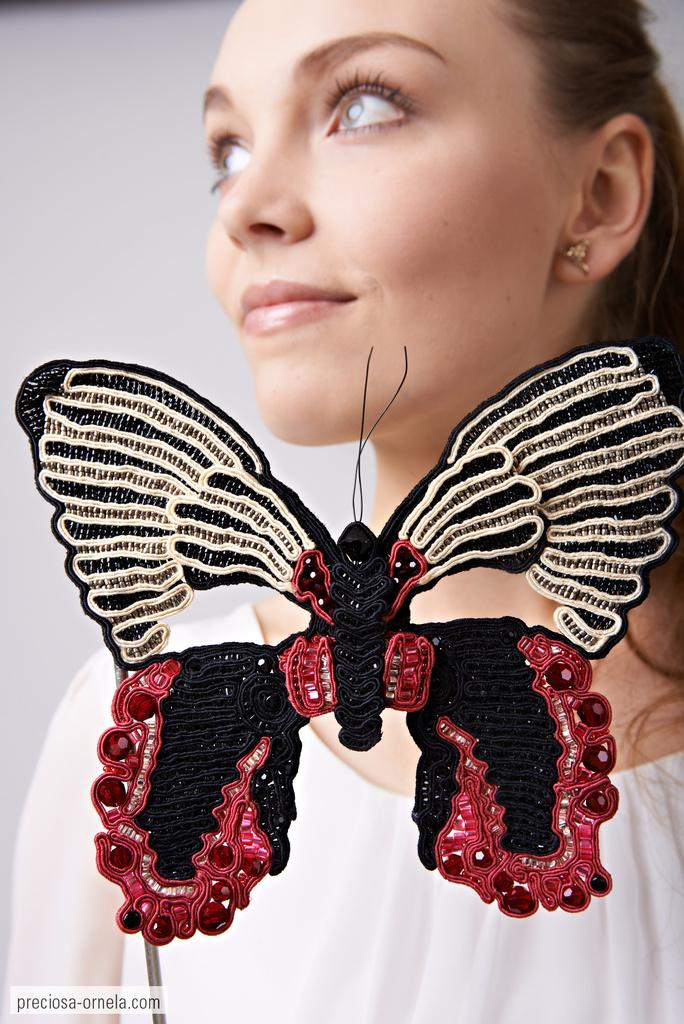Who is present in the image? There is a woman in the image. What object is in front of the woman? There is a butterfly toy in front of the woman. What time is displayed on the clock on the table in the image? There is no clock or table present in the image. 